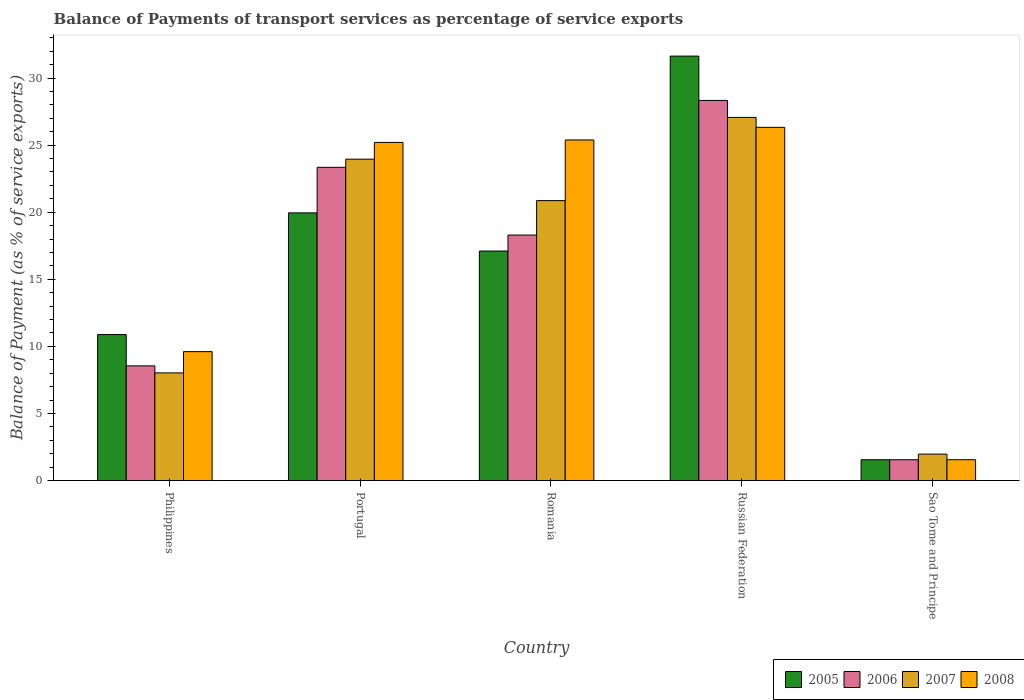How many groups of bars are there?
Provide a succinct answer. 5. Are the number of bars per tick equal to the number of legend labels?
Keep it short and to the point. Yes. Are the number of bars on each tick of the X-axis equal?
Offer a terse response. Yes. How many bars are there on the 4th tick from the left?
Your answer should be very brief. 4. What is the label of the 2nd group of bars from the left?
Provide a succinct answer. Portugal. In how many cases, is the number of bars for a given country not equal to the number of legend labels?
Provide a short and direct response. 0. What is the balance of payments of transport services in 2008 in Russian Federation?
Keep it short and to the point. 26.32. Across all countries, what is the maximum balance of payments of transport services in 2008?
Your answer should be very brief. 26.32. Across all countries, what is the minimum balance of payments of transport services in 2005?
Your answer should be compact. 1.55. In which country was the balance of payments of transport services in 2005 maximum?
Offer a terse response. Russian Federation. In which country was the balance of payments of transport services in 2007 minimum?
Keep it short and to the point. Sao Tome and Principe. What is the total balance of payments of transport services in 2008 in the graph?
Your response must be concise. 88.07. What is the difference between the balance of payments of transport services in 2008 in Portugal and that in Russian Federation?
Your answer should be compact. -1.12. What is the difference between the balance of payments of transport services in 2007 in Romania and the balance of payments of transport services in 2006 in Portugal?
Keep it short and to the point. -2.48. What is the average balance of payments of transport services in 2008 per country?
Your response must be concise. 17.61. What is the difference between the balance of payments of transport services of/in 2007 and balance of payments of transport services of/in 2005 in Philippines?
Provide a succinct answer. -2.86. In how many countries, is the balance of payments of transport services in 2006 greater than 21 %?
Your answer should be compact. 2. What is the ratio of the balance of payments of transport services in 2008 in Philippines to that in Russian Federation?
Give a very brief answer. 0.37. Is the balance of payments of transport services in 2008 in Philippines less than that in Sao Tome and Principe?
Your answer should be compact. No. What is the difference between the highest and the second highest balance of payments of transport services in 2007?
Provide a succinct answer. 6.2. What is the difference between the highest and the lowest balance of payments of transport services in 2006?
Ensure brevity in your answer.  26.77. In how many countries, is the balance of payments of transport services in 2008 greater than the average balance of payments of transport services in 2008 taken over all countries?
Ensure brevity in your answer.  3. Is it the case that in every country, the sum of the balance of payments of transport services in 2008 and balance of payments of transport services in 2007 is greater than the sum of balance of payments of transport services in 2005 and balance of payments of transport services in 2006?
Your answer should be very brief. No. What does the 4th bar from the left in Philippines represents?
Provide a short and direct response. 2008. What does the 2nd bar from the right in Philippines represents?
Provide a succinct answer. 2007. Is it the case that in every country, the sum of the balance of payments of transport services in 2008 and balance of payments of transport services in 2006 is greater than the balance of payments of transport services in 2007?
Give a very brief answer. Yes. How many bars are there?
Ensure brevity in your answer.  20. Where does the legend appear in the graph?
Provide a short and direct response. Bottom right. How many legend labels are there?
Keep it short and to the point. 4. How are the legend labels stacked?
Keep it short and to the point. Horizontal. What is the title of the graph?
Make the answer very short. Balance of Payments of transport services as percentage of service exports. Does "2009" appear as one of the legend labels in the graph?
Keep it short and to the point. No. What is the label or title of the Y-axis?
Provide a succinct answer. Balance of Payment (as % of service exports). What is the Balance of Payment (as % of service exports) in 2005 in Philippines?
Provide a short and direct response. 10.88. What is the Balance of Payment (as % of service exports) in 2006 in Philippines?
Offer a terse response. 8.55. What is the Balance of Payment (as % of service exports) of 2007 in Philippines?
Your response must be concise. 8.02. What is the Balance of Payment (as % of service exports) of 2008 in Philippines?
Ensure brevity in your answer.  9.61. What is the Balance of Payment (as % of service exports) of 2005 in Portugal?
Your answer should be compact. 19.95. What is the Balance of Payment (as % of service exports) of 2006 in Portugal?
Give a very brief answer. 23.34. What is the Balance of Payment (as % of service exports) in 2007 in Portugal?
Your answer should be very brief. 23.95. What is the Balance of Payment (as % of service exports) of 2008 in Portugal?
Ensure brevity in your answer.  25.2. What is the Balance of Payment (as % of service exports) of 2005 in Romania?
Ensure brevity in your answer.  17.11. What is the Balance of Payment (as % of service exports) of 2006 in Romania?
Offer a terse response. 18.3. What is the Balance of Payment (as % of service exports) in 2007 in Romania?
Provide a succinct answer. 20.86. What is the Balance of Payment (as % of service exports) of 2008 in Romania?
Your answer should be very brief. 25.38. What is the Balance of Payment (as % of service exports) in 2005 in Russian Federation?
Provide a short and direct response. 31.63. What is the Balance of Payment (as % of service exports) of 2006 in Russian Federation?
Keep it short and to the point. 28.33. What is the Balance of Payment (as % of service exports) in 2007 in Russian Federation?
Offer a very short reply. 27.06. What is the Balance of Payment (as % of service exports) of 2008 in Russian Federation?
Ensure brevity in your answer.  26.32. What is the Balance of Payment (as % of service exports) in 2005 in Sao Tome and Principe?
Your answer should be compact. 1.55. What is the Balance of Payment (as % of service exports) in 2006 in Sao Tome and Principe?
Provide a short and direct response. 1.55. What is the Balance of Payment (as % of service exports) in 2007 in Sao Tome and Principe?
Make the answer very short. 1.97. What is the Balance of Payment (as % of service exports) in 2008 in Sao Tome and Principe?
Your answer should be compact. 1.55. Across all countries, what is the maximum Balance of Payment (as % of service exports) of 2005?
Offer a very short reply. 31.63. Across all countries, what is the maximum Balance of Payment (as % of service exports) in 2006?
Give a very brief answer. 28.33. Across all countries, what is the maximum Balance of Payment (as % of service exports) of 2007?
Provide a succinct answer. 27.06. Across all countries, what is the maximum Balance of Payment (as % of service exports) in 2008?
Give a very brief answer. 26.32. Across all countries, what is the minimum Balance of Payment (as % of service exports) in 2005?
Your answer should be very brief. 1.55. Across all countries, what is the minimum Balance of Payment (as % of service exports) of 2006?
Make the answer very short. 1.55. Across all countries, what is the minimum Balance of Payment (as % of service exports) in 2007?
Make the answer very short. 1.97. Across all countries, what is the minimum Balance of Payment (as % of service exports) in 2008?
Your answer should be compact. 1.55. What is the total Balance of Payment (as % of service exports) of 2005 in the graph?
Offer a terse response. 81.12. What is the total Balance of Payment (as % of service exports) in 2006 in the graph?
Your response must be concise. 80.07. What is the total Balance of Payment (as % of service exports) of 2007 in the graph?
Your answer should be very brief. 81.87. What is the total Balance of Payment (as % of service exports) in 2008 in the graph?
Make the answer very short. 88.07. What is the difference between the Balance of Payment (as % of service exports) in 2005 in Philippines and that in Portugal?
Make the answer very short. -9.07. What is the difference between the Balance of Payment (as % of service exports) of 2006 in Philippines and that in Portugal?
Provide a succinct answer. -14.8. What is the difference between the Balance of Payment (as % of service exports) in 2007 in Philippines and that in Portugal?
Keep it short and to the point. -15.93. What is the difference between the Balance of Payment (as % of service exports) in 2008 in Philippines and that in Portugal?
Your answer should be very brief. -15.59. What is the difference between the Balance of Payment (as % of service exports) in 2005 in Philippines and that in Romania?
Keep it short and to the point. -6.23. What is the difference between the Balance of Payment (as % of service exports) in 2006 in Philippines and that in Romania?
Provide a succinct answer. -9.75. What is the difference between the Balance of Payment (as % of service exports) of 2007 in Philippines and that in Romania?
Provide a short and direct response. -12.84. What is the difference between the Balance of Payment (as % of service exports) in 2008 in Philippines and that in Romania?
Provide a succinct answer. -15.77. What is the difference between the Balance of Payment (as % of service exports) in 2005 in Philippines and that in Russian Federation?
Make the answer very short. -20.75. What is the difference between the Balance of Payment (as % of service exports) of 2006 in Philippines and that in Russian Federation?
Provide a short and direct response. -19.78. What is the difference between the Balance of Payment (as % of service exports) in 2007 in Philippines and that in Russian Federation?
Ensure brevity in your answer.  -19.04. What is the difference between the Balance of Payment (as % of service exports) of 2008 in Philippines and that in Russian Federation?
Provide a succinct answer. -16.71. What is the difference between the Balance of Payment (as % of service exports) of 2005 in Philippines and that in Sao Tome and Principe?
Your response must be concise. 9.33. What is the difference between the Balance of Payment (as % of service exports) in 2006 in Philippines and that in Sao Tome and Principe?
Ensure brevity in your answer.  6.99. What is the difference between the Balance of Payment (as % of service exports) in 2007 in Philippines and that in Sao Tome and Principe?
Ensure brevity in your answer.  6.05. What is the difference between the Balance of Payment (as % of service exports) of 2008 in Philippines and that in Sao Tome and Principe?
Your answer should be very brief. 8.06. What is the difference between the Balance of Payment (as % of service exports) of 2005 in Portugal and that in Romania?
Your answer should be very brief. 2.84. What is the difference between the Balance of Payment (as % of service exports) of 2006 in Portugal and that in Romania?
Your answer should be very brief. 5.05. What is the difference between the Balance of Payment (as % of service exports) of 2007 in Portugal and that in Romania?
Ensure brevity in your answer.  3.09. What is the difference between the Balance of Payment (as % of service exports) in 2008 in Portugal and that in Romania?
Your response must be concise. -0.18. What is the difference between the Balance of Payment (as % of service exports) of 2005 in Portugal and that in Russian Federation?
Give a very brief answer. -11.68. What is the difference between the Balance of Payment (as % of service exports) in 2006 in Portugal and that in Russian Federation?
Give a very brief answer. -4.98. What is the difference between the Balance of Payment (as % of service exports) in 2007 in Portugal and that in Russian Federation?
Provide a short and direct response. -3.11. What is the difference between the Balance of Payment (as % of service exports) of 2008 in Portugal and that in Russian Federation?
Your response must be concise. -1.12. What is the difference between the Balance of Payment (as % of service exports) in 2005 in Portugal and that in Sao Tome and Principe?
Your answer should be compact. 18.39. What is the difference between the Balance of Payment (as % of service exports) of 2006 in Portugal and that in Sao Tome and Principe?
Provide a succinct answer. 21.79. What is the difference between the Balance of Payment (as % of service exports) in 2007 in Portugal and that in Sao Tome and Principe?
Provide a short and direct response. 21.98. What is the difference between the Balance of Payment (as % of service exports) of 2008 in Portugal and that in Sao Tome and Principe?
Provide a short and direct response. 23.65. What is the difference between the Balance of Payment (as % of service exports) of 2005 in Romania and that in Russian Federation?
Your answer should be compact. -14.53. What is the difference between the Balance of Payment (as % of service exports) of 2006 in Romania and that in Russian Federation?
Keep it short and to the point. -10.03. What is the difference between the Balance of Payment (as % of service exports) in 2007 in Romania and that in Russian Federation?
Provide a succinct answer. -6.2. What is the difference between the Balance of Payment (as % of service exports) in 2008 in Romania and that in Russian Federation?
Provide a succinct answer. -0.94. What is the difference between the Balance of Payment (as % of service exports) in 2005 in Romania and that in Sao Tome and Principe?
Your answer should be very brief. 15.55. What is the difference between the Balance of Payment (as % of service exports) in 2006 in Romania and that in Sao Tome and Principe?
Offer a very short reply. 16.74. What is the difference between the Balance of Payment (as % of service exports) of 2007 in Romania and that in Sao Tome and Principe?
Your response must be concise. 18.89. What is the difference between the Balance of Payment (as % of service exports) in 2008 in Romania and that in Sao Tome and Principe?
Provide a short and direct response. 23.83. What is the difference between the Balance of Payment (as % of service exports) of 2005 in Russian Federation and that in Sao Tome and Principe?
Your answer should be compact. 30.08. What is the difference between the Balance of Payment (as % of service exports) in 2006 in Russian Federation and that in Sao Tome and Principe?
Ensure brevity in your answer.  26.77. What is the difference between the Balance of Payment (as % of service exports) in 2007 in Russian Federation and that in Sao Tome and Principe?
Provide a succinct answer. 25.09. What is the difference between the Balance of Payment (as % of service exports) in 2008 in Russian Federation and that in Sao Tome and Principe?
Make the answer very short. 24.77. What is the difference between the Balance of Payment (as % of service exports) of 2005 in Philippines and the Balance of Payment (as % of service exports) of 2006 in Portugal?
Give a very brief answer. -12.46. What is the difference between the Balance of Payment (as % of service exports) of 2005 in Philippines and the Balance of Payment (as % of service exports) of 2007 in Portugal?
Your answer should be compact. -13.07. What is the difference between the Balance of Payment (as % of service exports) in 2005 in Philippines and the Balance of Payment (as % of service exports) in 2008 in Portugal?
Your response must be concise. -14.32. What is the difference between the Balance of Payment (as % of service exports) of 2006 in Philippines and the Balance of Payment (as % of service exports) of 2007 in Portugal?
Offer a terse response. -15.4. What is the difference between the Balance of Payment (as % of service exports) of 2006 in Philippines and the Balance of Payment (as % of service exports) of 2008 in Portugal?
Keep it short and to the point. -16.65. What is the difference between the Balance of Payment (as % of service exports) of 2007 in Philippines and the Balance of Payment (as % of service exports) of 2008 in Portugal?
Ensure brevity in your answer.  -17.18. What is the difference between the Balance of Payment (as % of service exports) in 2005 in Philippines and the Balance of Payment (as % of service exports) in 2006 in Romania?
Offer a very short reply. -7.42. What is the difference between the Balance of Payment (as % of service exports) in 2005 in Philippines and the Balance of Payment (as % of service exports) in 2007 in Romania?
Offer a terse response. -9.98. What is the difference between the Balance of Payment (as % of service exports) in 2005 in Philippines and the Balance of Payment (as % of service exports) in 2008 in Romania?
Keep it short and to the point. -14.5. What is the difference between the Balance of Payment (as % of service exports) in 2006 in Philippines and the Balance of Payment (as % of service exports) in 2007 in Romania?
Your answer should be compact. -12.32. What is the difference between the Balance of Payment (as % of service exports) of 2006 in Philippines and the Balance of Payment (as % of service exports) of 2008 in Romania?
Give a very brief answer. -16.84. What is the difference between the Balance of Payment (as % of service exports) in 2007 in Philippines and the Balance of Payment (as % of service exports) in 2008 in Romania?
Give a very brief answer. -17.36. What is the difference between the Balance of Payment (as % of service exports) of 2005 in Philippines and the Balance of Payment (as % of service exports) of 2006 in Russian Federation?
Your answer should be compact. -17.45. What is the difference between the Balance of Payment (as % of service exports) of 2005 in Philippines and the Balance of Payment (as % of service exports) of 2007 in Russian Federation?
Give a very brief answer. -16.18. What is the difference between the Balance of Payment (as % of service exports) in 2005 in Philippines and the Balance of Payment (as % of service exports) in 2008 in Russian Federation?
Ensure brevity in your answer.  -15.44. What is the difference between the Balance of Payment (as % of service exports) of 2006 in Philippines and the Balance of Payment (as % of service exports) of 2007 in Russian Federation?
Give a very brief answer. -18.51. What is the difference between the Balance of Payment (as % of service exports) in 2006 in Philippines and the Balance of Payment (as % of service exports) in 2008 in Russian Federation?
Offer a terse response. -17.77. What is the difference between the Balance of Payment (as % of service exports) of 2007 in Philippines and the Balance of Payment (as % of service exports) of 2008 in Russian Federation?
Your answer should be compact. -18.3. What is the difference between the Balance of Payment (as % of service exports) of 2005 in Philippines and the Balance of Payment (as % of service exports) of 2006 in Sao Tome and Principe?
Give a very brief answer. 9.33. What is the difference between the Balance of Payment (as % of service exports) in 2005 in Philippines and the Balance of Payment (as % of service exports) in 2007 in Sao Tome and Principe?
Your answer should be compact. 8.91. What is the difference between the Balance of Payment (as % of service exports) in 2005 in Philippines and the Balance of Payment (as % of service exports) in 2008 in Sao Tome and Principe?
Provide a succinct answer. 9.33. What is the difference between the Balance of Payment (as % of service exports) in 2006 in Philippines and the Balance of Payment (as % of service exports) in 2007 in Sao Tome and Principe?
Your answer should be very brief. 6.58. What is the difference between the Balance of Payment (as % of service exports) of 2006 in Philippines and the Balance of Payment (as % of service exports) of 2008 in Sao Tome and Principe?
Provide a short and direct response. 6.99. What is the difference between the Balance of Payment (as % of service exports) in 2007 in Philippines and the Balance of Payment (as % of service exports) in 2008 in Sao Tome and Principe?
Provide a succinct answer. 6.47. What is the difference between the Balance of Payment (as % of service exports) in 2005 in Portugal and the Balance of Payment (as % of service exports) in 2006 in Romania?
Ensure brevity in your answer.  1.65. What is the difference between the Balance of Payment (as % of service exports) in 2005 in Portugal and the Balance of Payment (as % of service exports) in 2007 in Romania?
Provide a short and direct response. -0.91. What is the difference between the Balance of Payment (as % of service exports) of 2005 in Portugal and the Balance of Payment (as % of service exports) of 2008 in Romania?
Provide a succinct answer. -5.43. What is the difference between the Balance of Payment (as % of service exports) of 2006 in Portugal and the Balance of Payment (as % of service exports) of 2007 in Romania?
Offer a very short reply. 2.48. What is the difference between the Balance of Payment (as % of service exports) in 2006 in Portugal and the Balance of Payment (as % of service exports) in 2008 in Romania?
Offer a terse response. -2.04. What is the difference between the Balance of Payment (as % of service exports) in 2007 in Portugal and the Balance of Payment (as % of service exports) in 2008 in Romania?
Your response must be concise. -1.43. What is the difference between the Balance of Payment (as % of service exports) in 2005 in Portugal and the Balance of Payment (as % of service exports) in 2006 in Russian Federation?
Keep it short and to the point. -8.38. What is the difference between the Balance of Payment (as % of service exports) in 2005 in Portugal and the Balance of Payment (as % of service exports) in 2007 in Russian Federation?
Provide a short and direct response. -7.11. What is the difference between the Balance of Payment (as % of service exports) in 2005 in Portugal and the Balance of Payment (as % of service exports) in 2008 in Russian Federation?
Offer a very short reply. -6.37. What is the difference between the Balance of Payment (as % of service exports) in 2006 in Portugal and the Balance of Payment (as % of service exports) in 2007 in Russian Federation?
Provide a short and direct response. -3.72. What is the difference between the Balance of Payment (as % of service exports) of 2006 in Portugal and the Balance of Payment (as % of service exports) of 2008 in Russian Federation?
Offer a terse response. -2.98. What is the difference between the Balance of Payment (as % of service exports) of 2007 in Portugal and the Balance of Payment (as % of service exports) of 2008 in Russian Federation?
Give a very brief answer. -2.37. What is the difference between the Balance of Payment (as % of service exports) of 2005 in Portugal and the Balance of Payment (as % of service exports) of 2006 in Sao Tome and Principe?
Ensure brevity in your answer.  18.39. What is the difference between the Balance of Payment (as % of service exports) in 2005 in Portugal and the Balance of Payment (as % of service exports) in 2007 in Sao Tome and Principe?
Your answer should be compact. 17.98. What is the difference between the Balance of Payment (as % of service exports) in 2005 in Portugal and the Balance of Payment (as % of service exports) in 2008 in Sao Tome and Principe?
Offer a very short reply. 18.39. What is the difference between the Balance of Payment (as % of service exports) in 2006 in Portugal and the Balance of Payment (as % of service exports) in 2007 in Sao Tome and Principe?
Keep it short and to the point. 21.37. What is the difference between the Balance of Payment (as % of service exports) of 2006 in Portugal and the Balance of Payment (as % of service exports) of 2008 in Sao Tome and Principe?
Make the answer very short. 21.79. What is the difference between the Balance of Payment (as % of service exports) in 2007 in Portugal and the Balance of Payment (as % of service exports) in 2008 in Sao Tome and Principe?
Your answer should be compact. 22.4. What is the difference between the Balance of Payment (as % of service exports) of 2005 in Romania and the Balance of Payment (as % of service exports) of 2006 in Russian Federation?
Offer a terse response. -11.22. What is the difference between the Balance of Payment (as % of service exports) of 2005 in Romania and the Balance of Payment (as % of service exports) of 2007 in Russian Federation?
Offer a very short reply. -9.96. What is the difference between the Balance of Payment (as % of service exports) of 2005 in Romania and the Balance of Payment (as % of service exports) of 2008 in Russian Federation?
Make the answer very short. -9.22. What is the difference between the Balance of Payment (as % of service exports) in 2006 in Romania and the Balance of Payment (as % of service exports) in 2007 in Russian Federation?
Provide a succinct answer. -8.77. What is the difference between the Balance of Payment (as % of service exports) in 2006 in Romania and the Balance of Payment (as % of service exports) in 2008 in Russian Federation?
Your answer should be very brief. -8.03. What is the difference between the Balance of Payment (as % of service exports) in 2007 in Romania and the Balance of Payment (as % of service exports) in 2008 in Russian Federation?
Your response must be concise. -5.46. What is the difference between the Balance of Payment (as % of service exports) in 2005 in Romania and the Balance of Payment (as % of service exports) in 2006 in Sao Tome and Principe?
Your answer should be very brief. 15.55. What is the difference between the Balance of Payment (as % of service exports) of 2005 in Romania and the Balance of Payment (as % of service exports) of 2007 in Sao Tome and Principe?
Keep it short and to the point. 15.14. What is the difference between the Balance of Payment (as % of service exports) of 2005 in Romania and the Balance of Payment (as % of service exports) of 2008 in Sao Tome and Principe?
Your response must be concise. 15.55. What is the difference between the Balance of Payment (as % of service exports) of 2006 in Romania and the Balance of Payment (as % of service exports) of 2007 in Sao Tome and Principe?
Keep it short and to the point. 16.32. What is the difference between the Balance of Payment (as % of service exports) of 2006 in Romania and the Balance of Payment (as % of service exports) of 2008 in Sao Tome and Principe?
Your response must be concise. 16.74. What is the difference between the Balance of Payment (as % of service exports) in 2007 in Romania and the Balance of Payment (as % of service exports) in 2008 in Sao Tome and Principe?
Provide a short and direct response. 19.31. What is the difference between the Balance of Payment (as % of service exports) of 2005 in Russian Federation and the Balance of Payment (as % of service exports) of 2006 in Sao Tome and Principe?
Offer a very short reply. 30.08. What is the difference between the Balance of Payment (as % of service exports) of 2005 in Russian Federation and the Balance of Payment (as % of service exports) of 2007 in Sao Tome and Principe?
Your answer should be compact. 29.66. What is the difference between the Balance of Payment (as % of service exports) in 2005 in Russian Federation and the Balance of Payment (as % of service exports) in 2008 in Sao Tome and Principe?
Provide a succinct answer. 30.08. What is the difference between the Balance of Payment (as % of service exports) in 2006 in Russian Federation and the Balance of Payment (as % of service exports) in 2007 in Sao Tome and Principe?
Your response must be concise. 26.36. What is the difference between the Balance of Payment (as % of service exports) in 2006 in Russian Federation and the Balance of Payment (as % of service exports) in 2008 in Sao Tome and Principe?
Offer a very short reply. 26.77. What is the difference between the Balance of Payment (as % of service exports) in 2007 in Russian Federation and the Balance of Payment (as % of service exports) in 2008 in Sao Tome and Principe?
Provide a succinct answer. 25.51. What is the average Balance of Payment (as % of service exports) of 2005 per country?
Your answer should be very brief. 16.22. What is the average Balance of Payment (as % of service exports) in 2006 per country?
Provide a short and direct response. 16.01. What is the average Balance of Payment (as % of service exports) in 2007 per country?
Provide a succinct answer. 16.37. What is the average Balance of Payment (as % of service exports) of 2008 per country?
Your answer should be very brief. 17.61. What is the difference between the Balance of Payment (as % of service exports) in 2005 and Balance of Payment (as % of service exports) in 2006 in Philippines?
Offer a very short reply. 2.33. What is the difference between the Balance of Payment (as % of service exports) in 2005 and Balance of Payment (as % of service exports) in 2007 in Philippines?
Your answer should be compact. 2.86. What is the difference between the Balance of Payment (as % of service exports) of 2005 and Balance of Payment (as % of service exports) of 2008 in Philippines?
Give a very brief answer. 1.27. What is the difference between the Balance of Payment (as % of service exports) in 2006 and Balance of Payment (as % of service exports) in 2007 in Philippines?
Offer a very short reply. 0.52. What is the difference between the Balance of Payment (as % of service exports) of 2006 and Balance of Payment (as % of service exports) of 2008 in Philippines?
Your response must be concise. -1.06. What is the difference between the Balance of Payment (as % of service exports) in 2007 and Balance of Payment (as % of service exports) in 2008 in Philippines?
Your response must be concise. -1.58. What is the difference between the Balance of Payment (as % of service exports) in 2005 and Balance of Payment (as % of service exports) in 2006 in Portugal?
Your response must be concise. -3.4. What is the difference between the Balance of Payment (as % of service exports) in 2005 and Balance of Payment (as % of service exports) in 2007 in Portugal?
Your answer should be compact. -4. What is the difference between the Balance of Payment (as % of service exports) in 2005 and Balance of Payment (as % of service exports) in 2008 in Portugal?
Make the answer very short. -5.25. What is the difference between the Balance of Payment (as % of service exports) in 2006 and Balance of Payment (as % of service exports) in 2007 in Portugal?
Ensure brevity in your answer.  -0.61. What is the difference between the Balance of Payment (as % of service exports) in 2006 and Balance of Payment (as % of service exports) in 2008 in Portugal?
Your answer should be very brief. -1.86. What is the difference between the Balance of Payment (as % of service exports) of 2007 and Balance of Payment (as % of service exports) of 2008 in Portugal?
Your answer should be very brief. -1.25. What is the difference between the Balance of Payment (as % of service exports) in 2005 and Balance of Payment (as % of service exports) in 2006 in Romania?
Offer a very short reply. -1.19. What is the difference between the Balance of Payment (as % of service exports) in 2005 and Balance of Payment (as % of service exports) in 2007 in Romania?
Make the answer very short. -3.76. What is the difference between the Balance of Payment (as % of service exports) in 2005 and Balance of Payment (as % of service exports) in 2008 in Romania?
Make the answer very short. -8.28. What is the difference between the Balance of Payment (as % of service exports) in 2006 and Balance of Payment (as % of service exports) in 2007 in Romania?
Keep it short and to the point. -2.57. What is the difference between the Balance of Payment (as % of service exports) in 2006 and Balance of Payment (as % of service exports) in 2008 in Romania?
Offer a very short reply. -7.09. What is the difference between the Balance of Payment (as % of service exports) in 2007 and Balance of Payment (as % of service exports) in 2008 in Romania?
Make the answer very short. -4.52. What is the difference between the Balance of Payment (as % of service exports) of 2005 and Balance of Payment (as % of service exports) of 2006 in Russian Federation?
Your response must be concise. 3.3. What is the difference between the Balance of Payment (as % of service exports) in 2005 and Balance of Payment (as % of service exports) in 2007 in Russian Federation?
Your answer should be compact. 4.57. What is the difference between the Balance of Payment (as % of service exports) of 2005 and Balance of Payment (as % of service exports) of 2008 in Russian Federation?
Give a very brief answer. 5.31. What is the difference between the Balance of Payment (as % of service exports) in 2006 and Balance of Payment (as % of service exports) in 2007 in Russian Federation?
Provide a short and direct response. 1.27. What is the difference between the Balance of Payment (as % of service exports) of 2006 and Balance of Payment (as % of service exports) of 2008 in Russian Federation?
Ensure brevity in your answer.  2.01. What is the difference between the Balance of Payment (as % of service exports) in 2007 and Balance of Payment (as % of service exports) in 2008 in Russian Federation?
Provide a succinct answer. 0.74. What is the difference between the Balance of Payment (as % of service exports) of 2005 and Balance of Payment (as % of service exports) of 2006 in Sao Tome and Principe?
Keep it short and to the point. 0. What is the difference between the Balance of Payment (as % of service exports) in 2005 and Balance of Payment (as % of service exports) in 2007 in Sao Tome and Principe?
Your answer should be compact. -0.42. What is the difference between the Balance of Payment (as % of service exports) of 2006 and Balance of Payment (as % of service exports) of 2007 in Sao Tome and Principe?
Offer a terse response. -0.42. What is the difference between the Balance of Payment (as % of service exports) of 2007 and Balance of Payment (as % of service exports) of 2008 in Sao Tome and Principe?
Your response must be concise. 0.42. What is the ratio of the Balance of Payment (as % of service exports) in 2005 in Philippines to that in Portugal?
Your answer should be compact. 0.55. What is the ratio of the Balance of Payment (as % of service exports) of 2006 in Philippines to that in Portugal?
Your answer should be compact. 0.37. What is the ratio of the Balance of Payment (as % of service exports) in 2007 in Philippines to that in Portugal?
Your answer should be compact. 0.34. What is the ratio of the Balance of Payment (as % of service exports) in 2008 in Philippines to that in Portugal?
Your response must be concise. 0.38. What is the ratio of the Balance of Payment (as % of service exports) in 2005 in Philippines to that in Romania?
Give a very brief answer. 0.64. What is the ratio of the Balance of Payment (as % of service exports) in 2006 in Philippines to that in Romania?
Ensure brevity in your answer.  0.47. What is the ratio of the Balance of Payment (as % of service exports) of 2007 in Philippines to that in Romania?
Ensure brevity in your answer.  0.38. What is the ratio of the Balance of Payment (as % of service exports) in 2008 in Philippines to that in Romania?
Give a very brief answer. 0.38. What is the ratio of the Balance of Payment (as % of service exports) of 2005 in Philippines to that in Russian Federation?
Your answer should be very brief. 0.34. What is the ratio of the Balance of Payment (as % of service exports) in 2006 in Philippines to that in Russian Federation?
Offer a terse response. 0.3. What is the ratio of the Balance of Payment (as % of service exports) in 2007 in Philippines to that in Russian Federation?
Give a very brief answer. 0.3. What is the ratio of the Balance of Payment (as % of service exports) in 2008 in Philippines to that in Russian Federation?
Provide a succinct answer. 0.37. What is the ratio of the Balance of Payment (as % of service exports) in 2005 in Philippines to that in Sao Tome and Principe?
Ensure brevity in your answer.  7. What is the ratio of the Balance of Payment (as % of service exports) of 2006 in Philippines to that in Sao Tome and Principe?
Provide a short and direct response. 5.5. What is the ratio of the Balance of Payment (as % of service exports) of 2007 in Philippines to that in Sao Tome and Principe?
Your answer should be very brief. 4.07. What is the ratio of the Balance of Payment (as % of service exports) of 2008 in Philippines to that in Sao Tome and Principe?
Your answer should be compact. 6.18. What is the ratio of the Balance of Payment (as % of service exports) in 2005 in Portugal to that in Romania?
Make the answer very short. 1.17. What is the ratio of the Balance of Payment (as % of service exports) in 2006 in Portugal to that in Romania?
Provide a short and direct response. 1.28. What is the ratio of the Balance of Payment (as % of service exports) in 2007 in Portugal to that in Romania?
Your response must be concise. 1.15. What is the ratio of the Balance of Payment (as % of service exports) in 2005 in Portugal to that in Russian Federation?
Offer a terse response. 0.63. What is the ratio of the Balance of Payment (as % of service exports) of 2006 in Portugal to that in Russian Federation?
Your response must be concise. 0.82. What is the ratio of the Balance of Payment (as % of service exports) in 2007 in Portugal to that in Russian Federation?
Your response must be concise. 0.89. What is the ratio of the Balance of Payment (as % of service exports) in 2008 in Portugal to that in Russian Federation?
Ensure brevity in your answer.  0.96. What is the ratio of the Balance of Payment (as % of service exports) of 2005 in Portugal to that in Sao Tome and Principe?
Provide a succinct answer. 12.84. What is the ratio of the Balance of Payment (as % of service exports) of 2006 in Portugal to that in Sao Tome and Principe?
Provide a succinct answer. 15.02. What is the ratio of the Balance of Payment (as % of service exports) in 2007 in Portugal to that in Sao Tome and Principe?
Keep it short and to the point. 12.15. What is the ratio of the Balance of Payment (as % of service exports) of 2008 in Portugal to that in Sao Tome and Principe?
Offer a terse response. 16.22. What is the ratio of the Balance of Payment (as % of service exports) of 2005 in Romania to that in Russian Federation?
Your answer should be compact. 0.54. What is the ratio of the Balance of Payment (as % of service exports) of 2006 in Romania to that in Russian Federation?
Your answer should be compact. 0.65. What is the ratio of the Balance of Payment (as % of service exports) in 2007 in Romania to that in Russian Federation?
Ensure brevity in your answer.  0.77. What is the ratio of the Balance of Payment (as % of service exports) of 2005 in Romania to that in Sao Tome and Principe?
Your answer should be compact. 11.01. What is the ratio of the Balance of Payment (as % of service exports) of 2006 in Romania to that in Sao Tome and Principe?
Your response must be concise. 11.77. What is the ratio of the Balance of Payment (as % of service exports) in 2007 in Romania to that in Sao Tome and Principe?
Make the answer very short. 10.58. What is the ratio of the Balance of Payment (as % of service exports) in 2008 in Romania to that in Sao Tome and Principe?
Ensure brevity in your answer.  16.33. What is the ratio of the Balance of Payment (as % of service exports) in 2005 in Russian Federation to that in Sao Tome and Principe?
Your answer should be compact. 20.36. What is the ratio of the Balance of Payment (as % of service exports) in 2006 in Russian Federation to that in Sao Tome and Principe?
Ensure brevity in your answer.  18.23. What is the ratio of the Balance of Payment (as % of service exports) of 2007 in Russian Federation to that in Sao Tome and Principe?
Your answer should be very brief. 13.73. What is the ratio of the Balance of Payment (as % of service exports) in 2008 in Russian Federation to that in Sao Tome and Principe?
Provide a short and direct response. 16.94. What is the difference between the highest and the second highest Balance of Payment (as % of service exports) in 2005?
Provide a succinct answer. 11.68. What is the difference between the highest and the second highest Balance of Payment (as % of service exports) in 2006?
Offer a terse response. 4.98. What is the difference between the highest and the second highest Balance of Payment (as % of service exports) of 2007?
Make the answer very short. 3.11. What is the difference between the highest and the second highest Balance of Payment (as % of service exports) in 2008?
Give a very brief answer. 0.94. What is the difference between the highest and the lowest Balance of Payment (as % of service exports) of 2005?
Your answer should be very brief. 30.08. What is the difference between the highest and the lowest Balance of Payment (as % of service exports) of 2006?
Make the answer very short. 26.77. What is the difference between the highest and the lowest Balance of Payment (as % of service exports) in 2007?
Provide a succinct answer. 25.09. What is the difference between the highest and the lowest Balance of Payment (as % of service exports) in 2008?
Provide a short and direct response. 24.77. 